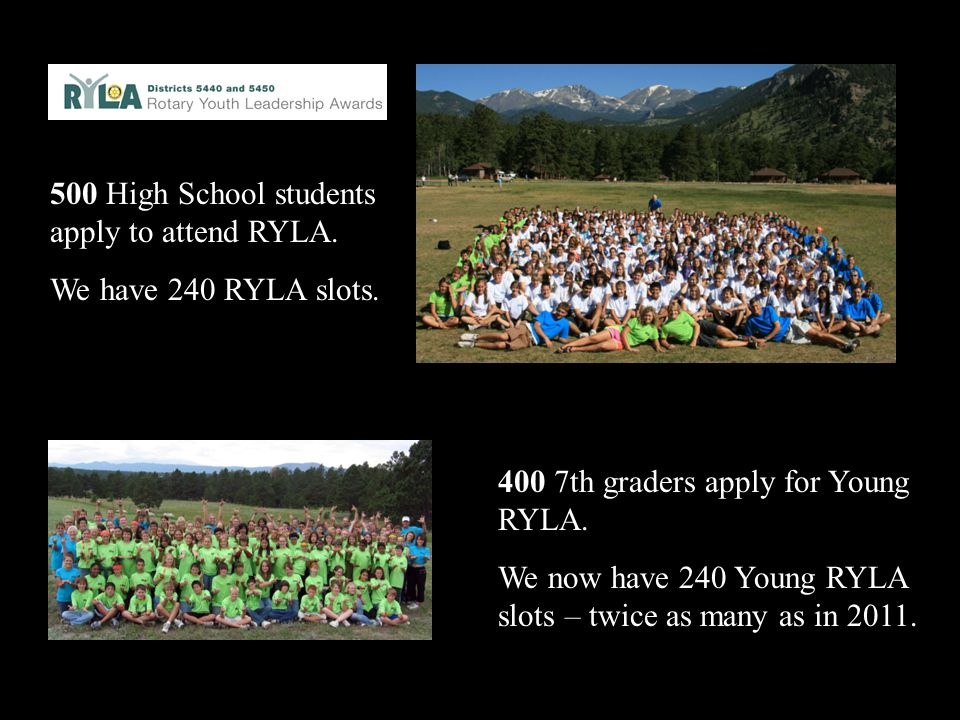How might the doubling of slots for the Young RYLA program since 2011 impact the local community? The doubling of slots for the Young RYLA program since 2011 could have a substantial positive impact on the local community. More participants mean that more young individuals are receiving valuable leadership training, which they can bring back to their schools, neighborhoods, and community groups. This increased pool of trained youth leaders can lead to more community projects, improved local initiatives, and greater civic engagement. Additionally, parents, educators, and community members may see the benefits of the program firsthand, inspiring further support and collaboration. Over time, this can foster a stronger, more resilient community with leaders who are well-prepared to address local challenges and opportunities.  What types of skills are most likely being developed through the Young RYLA program? The Young RYLA program is likely focusing on developing a variety of essential skills for young leaders. These skills include effective communication, both verbal and written, to ensure clear expression of ideas and active listening. Teamwork is another critical area, as it fosters collaboration, trust, and synergy among diverse groups. The program also likely emphasizes problem-solving and decision-making, training participants to think critically and make informed choices. Leadership and management skills are central, including setting goals, motivating others, and organizing projects. Additionally, participants probably develop personal qualities such as resilience, confidence, and empathy, crucial for leading with integrity and understanding. 